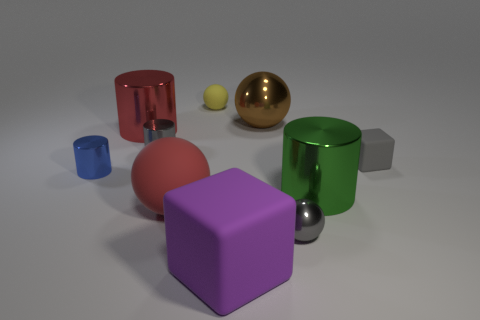There is a cylinder that is both on the right side of the red metal thing and on the left side of the red sphere; how big is it?
Your answer should be very brief. Small. What number of shiny things are either big green things or red cylinders?
Give a very brief answer. 2. There is a big rubber object that is left of the small yellow rubber thing; is it the same shape as the tiny matte object that is to the left of the tiny gray rubber block?
Keep it short and to the point. Yes. Are there any other cubes made of the same material as the large cube?
Ensure brevity in your answer.  Yes. What color is the large matte ball?
Make the answer very short. Red. How big is the gray thing that is in front of the big matte ball?
Your answer should be very brief. Small. How many large metal things are the same color as the big rubber sphere?
Offer a terse response. 1. There is a small metal cylinder that is on the left side of the big red cylinder; are there any metal cylinders that are to the right of it?
Your answer should be very brief. Yes. There is a big ball that is in front of the red shiny object; is it the same color as the big shiny thing that is to the left of the brown metallic object?
Offer a terse response. Yes. What is the color of the matte sphere that is the same size as the gray matte thing?
Offer a terse response. Yellow. 